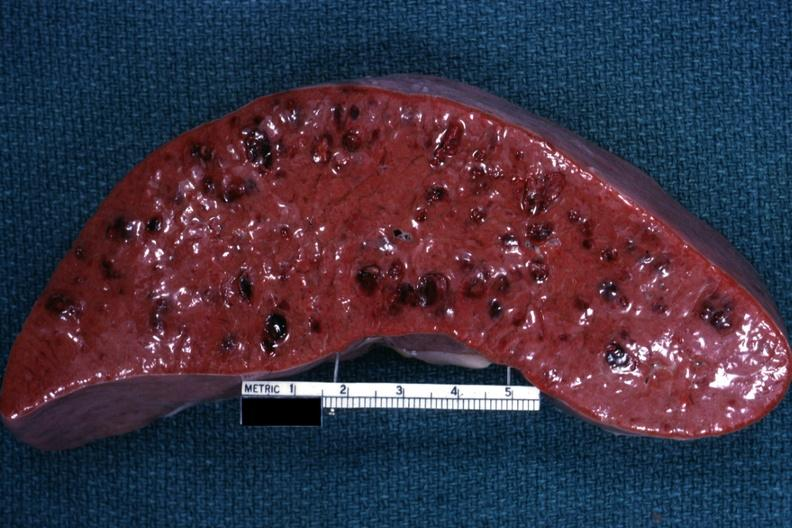s spleen present?
Answer the question using a single word or phrase. Yes 